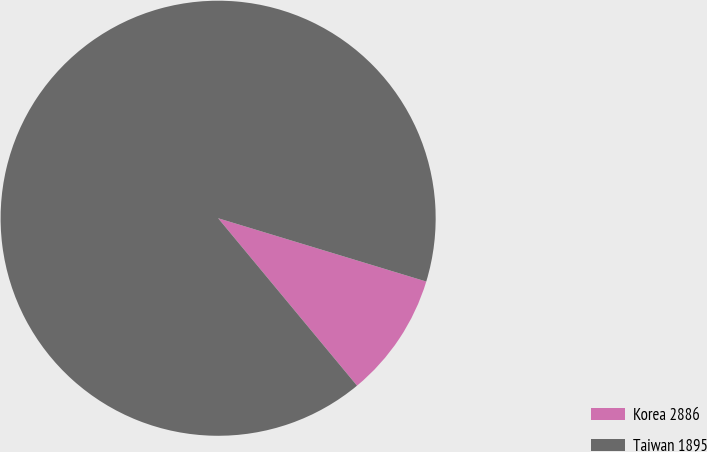Convert chart to OTSL. <chart><loc_0><loc_0><loc_500><loc_500><pie_chart><fcel>Korea 2886<fcel>Taiwan 1895<nl><fcel>9.28%<fcel>90.72%<nl></chart> 